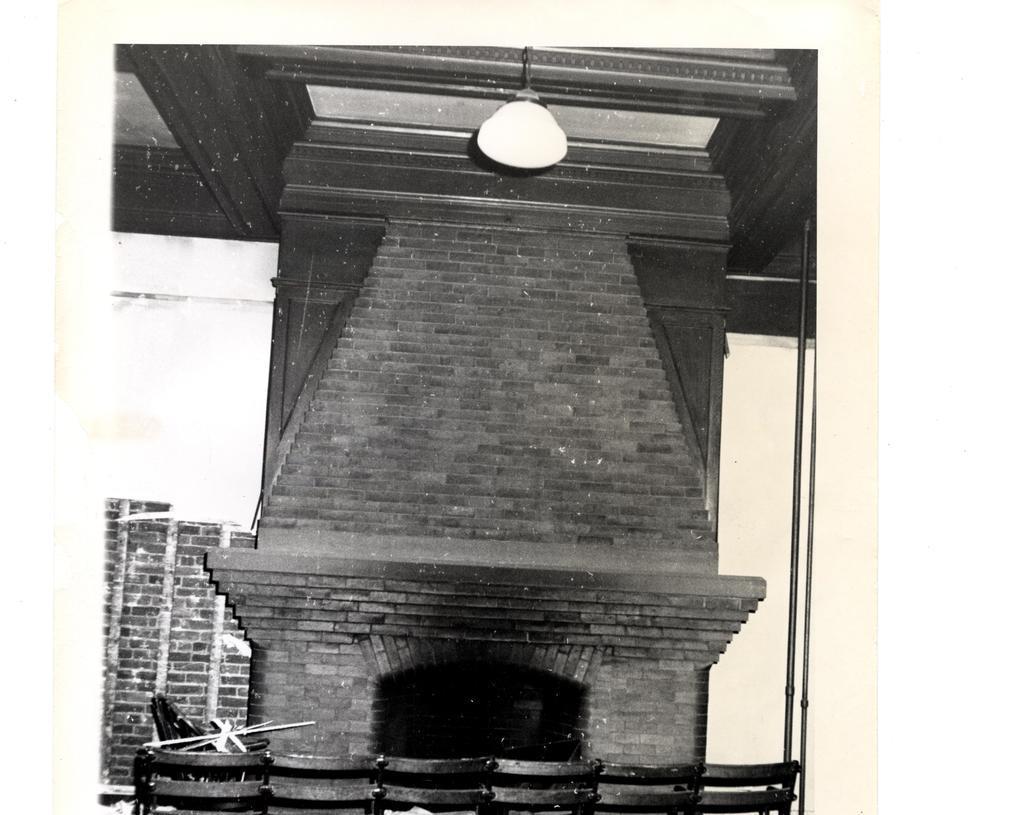Could you give a brief overview of what you see in this image? In this image, we can see a wall and there are some chairs, at the top there is a light. 